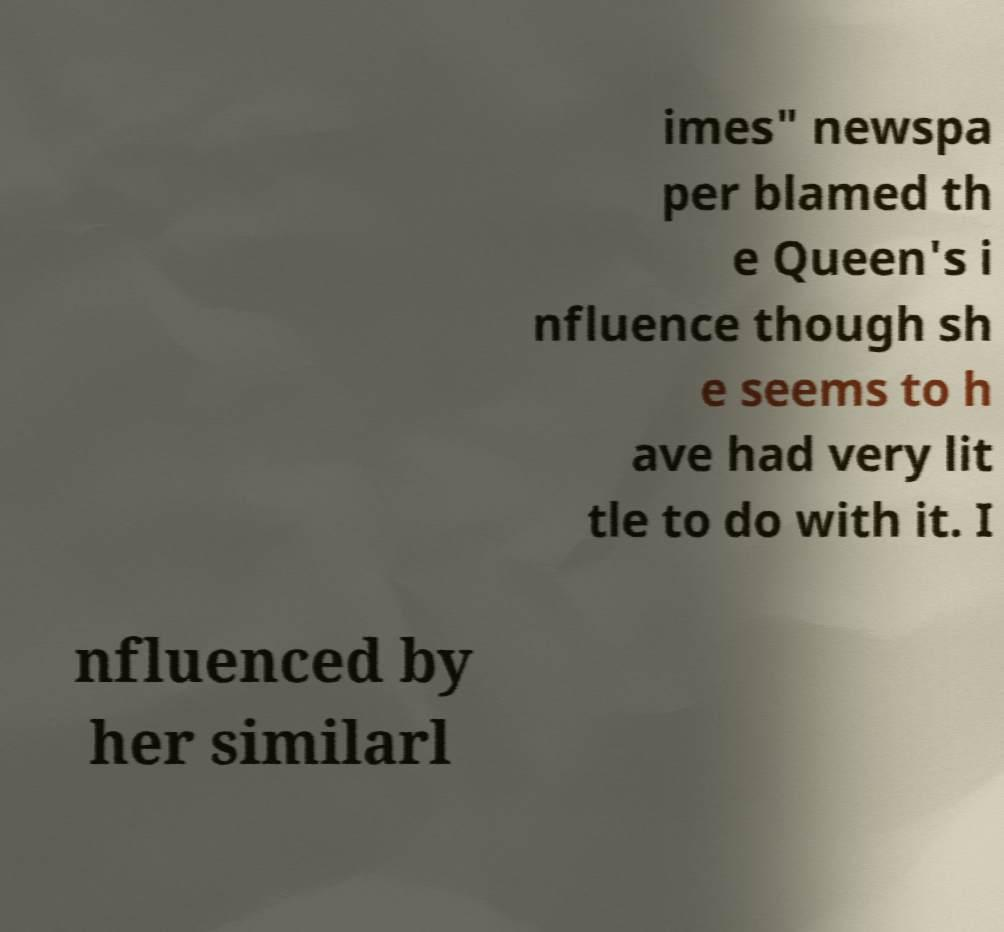What messages or text are displayed in this image? I need them in a readable, typed format. imes" newspa per blamed th e Queen's i nfluence though sh e seems to h ave had very lit tle to do with it. I nfluenced by her similarl 